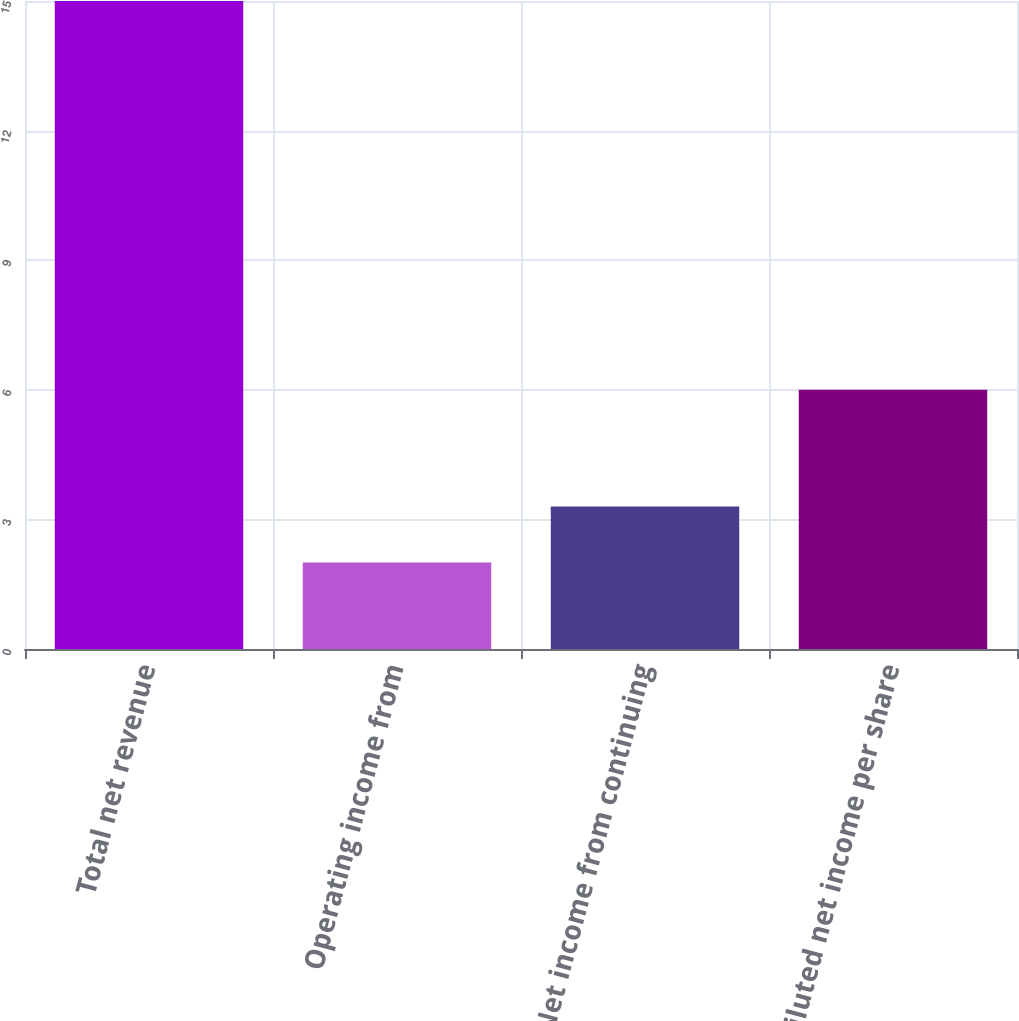<chart> <loc_0><loc_0><loc_500><loc_500><bar_chart><fcel>Total net revenue<fcel>Operating income from<fcel>Net income from continuing<fcel>Diluted net income per share<nl><fcel>15<fcel>2<fcel>3.3<fcel>6<nl></chart> 